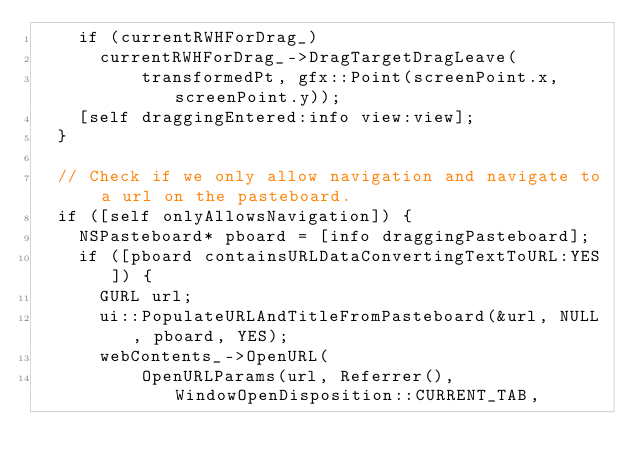Convert code to text. <code><loc_0><loc_0><loc_500><loc_500><_ObjectiveC_>    if (currentRWHForDrag_)
      currentRWHForDrag_->DragTargetDragLeave(
          transformedPt, gfx::Point(screenPoint.x, screenPoint.y));
    [self draggingEntered:info view:view];
  }

  // Check if we only allow navigation and navigate to a url on the pasteboard.
  if ([self onlyAllowsNavigation]) {
    NSPasteboard* pboard = [info draggingPasteboard];
    if ([pboard containsURLDataConvertingTextToURL:YES]) {
      GURL url;
      ui::PopulateURLAndTitleFromPasteboard(&url, NULL, pboard, YES);
      webContents_->OpenURL(
          OpenURLParams(url, Referrer(), WindowOpenDisposition::CURRENT_TAB,</code> 